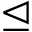<formula> <loc_0><loc_0><loc_500><loc_500>\triangleleft e q</formula> 